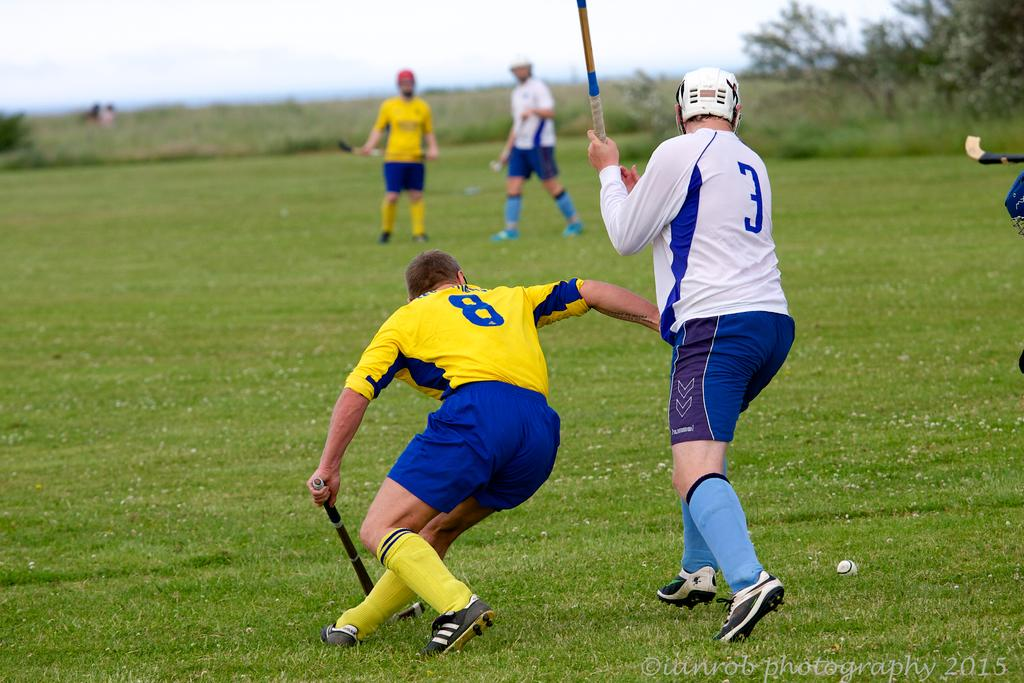Provide a one-sentence caption for the provided image. Team member number 3 stands with his stick up as opposing team member number 8 kneels with his stick down. 